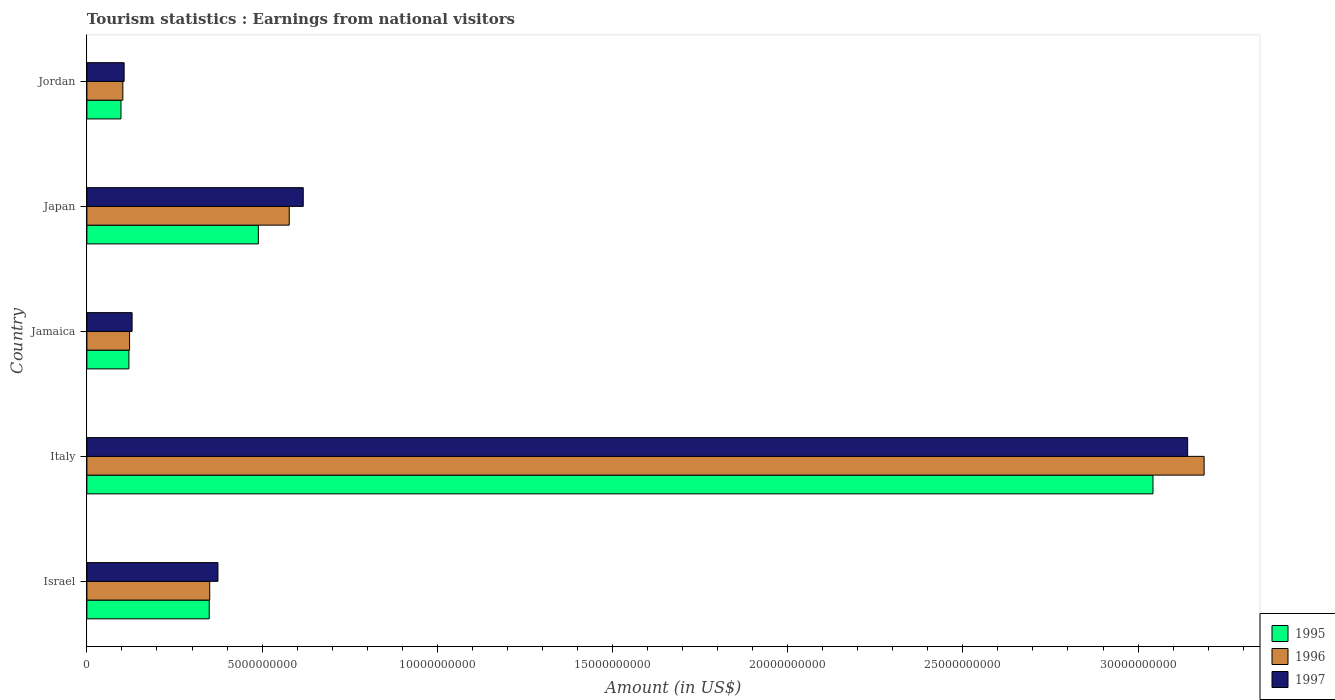How many different coloured bars are there?
Offer a very short reply. 3. Are the number of bars on each tick of the Y-axis equal?
Ensure brevity in your answer.  Yes. How many bars are there on the 1st tick from the bottom?
Keep it short and to the point. 3. What is the label of the 3rd group of bars from the top?
Ensure brevity in your answer.  Jamaica. In how many cases, is the number of bars for a given country not equal to the number of legend labels?
Your response must be concise. 0. What is the earnings from national visitors in 1995 in Italy?
Give a very brief answer. 3.04e+1. Across all countries, what is the maximum earnings from national visitors in 1997?
Your response must be concise. 3.14e+1. Across all countries, what is the minimum earnings from national visitors in 1996?
Provide a succinct answer. 1.03e+09. In which country was the earnings from national visitors in 1995 minimum?
Ensure brevity in your answer.  Jordan. What is the total earnings from national visitors in 1995 in the graph?
Your answer should be very brief. 4.10e+1. What is the difference between the earnings from national visitors in 1996 in Japan and that in Jordan?
Provide a short and direct response. 4.75e+09. What is the difference between the earnings from national visitors in 1997 in Italy and the earnings from national visitors in 1996 in Japan?
Your answer should be compact. 2.56e+1. What is the average earnings from national visitors in 1997 per country?
Provide a short and direct response. 8.74e+09. What is the difference between the earnings from national visitors in 1996 and earnings from national visitors in 1997 in Israel?
Give a very brief answer. -2.34e+08. In how many countries, is the earnings from national visitors in 1997 greater than 30000000000 US$?
Ensure brevity in your answer.  1. What is the ratio of the earnings from national visitors in 1997 in Japan to that in Jordan?
Provide a short and direct response. 5.81. Is the earnings from national visitors in 1996 in Israel less than that in Jordan?
Your answer should be very brief. No. Is the difference between the earnings from national visitors in 1996 in Italy and Jordan greater than the difference between the earnings from national visitors in 1997 in Italy and Jordan?
Your answer should be compact. Yes. What is the difference between the highest and the second highest earnings from national visitors in 1996?
Your answer should be compact. 2.61e+1. What is the difference between the highest and the lowest earnings from national visitors in 1995?
Ensure brevity in your answer.  2.95e+1. In how many countries, is the earnings from national visitors in 1995 greater than the average earnings from national visitors in 1995 taken over all countries?
Provide a short and direct response. 1. Is the sum of the earnings from national visitors in 1996 in Israel and Jamaica greater than the maximum earnings from national visitors in 1997 across all countries?
Provide a succinct answer. No. What does the 3rd bar from the top in Jamaica represents?
Provide a succinct answer. 1995. Is it the case that in every country, the sum of the earnings from national visitors in 1997 and earnings from national visitors in 1995 is greater than the earnings from national visitors in 1996?
Your answer should be compact. Yes. How many bars are there?
Provide a short and direct response. 15. How many countries are there in the graph?
Ensure brevity in your answer.  5. What is the difference between two consecutive major ticks on the X-axis?
Provide a succinct answer. 5.00e+09. Are the values on the major ticks of X-axis written in scientific E-notation?
Offer a terse response. No. Where does the legend appear in the graph?
Your answer should be compact. Bottom right. What is the title of the graph?
Your response must be concise. Tourism statistics : Earnings from national visitors. Does "1972" appear as one of the legend labels in the graph?
Your answer should be compact. No. What is the Amount (in US$) of 1995 in Israel?
Give a very brief answer. 3.49e+09. What is the Amount (in US$) in 1996 in Israel?
Offer a very short reply. 3.51e+09. What is the Amount (in US$) in 1997 in Israel?
Offer a terse response. 3.74e+09. What is the Amount (in US$) in 1995 in Italy?
Make the answer very short. 3.04e+1. What is the Amount (in US$) of 1996 in Italy?
Provide a succinct answer. 3.19e+1. What is the Amount (in US$) in 1997 in Italy?
Keep it short and to the point. 3.14e+1. What is the Amount (in US$) in 1995 in Jamaica?
Your answer should be very brief. 1.20e+09. What is the Amount (in US$) of 1996 in Jamaica?
Offer a very short reply. 1.22e+09. What is the Amount (in US$) of 1997 in Jamaica?
Provide a short and direct response. 1.29e+09. What is the Amount (in US$) of 1995 in Japan?
Give a very brief answer. 4.89e+09. What is the Amount (in US$) of 1996 in Japan?
Give a very brief answer. 5.78e+09. What is the Amount (in US$) of 1997 in Japan?
Make the answer very short. 6.18e+09. What is the Amount (in US$) of 1995 in Jordan?
Offer a terse response. 9.73e+08. What is the Amount (in US$) in 1996 in Jordan?
Make the answer very short. 1.03e+09. What is the Amount (in US$) in 1997 in Jordan?
Offer a very short reply. 1.06e+09. Across all countries, what is the maximum Amount (in US$) in 1995?
Offer a terse response. 3.04e+1. Across all countries, what is the maximum Amount (in US$) in 1996?
Provide a short and direct response. 3.19e+1. Across all countries, what is the maximum Amount (in US$) in 1997?
Your response must be concise. 3.14e+1. Across all countries, what is the minimum Amount (in US$) in 1995?
Your response must be concise. 9.73e+08. Across all countries, what is the minimum Amount (in US$) in 1996?
Your response must be concise. 1.03e+09. Across all countries, what is the minimum Amount (in US$) in 1997?
Offer a terse response. 1.06e+09. What is the total Amount (in US$) of 1995 in the graph?
Offer a terse response. 4.10e+1. What is the total Amount (in US$) in 1996 in the graph?
Offer a very short reply. 4.34e+1. What is the total Amount (in US$) of 1997 in the graph?
Offer a terse response. 4.37e+1. What is the difference between the Amount (in US$) in 1995 in Israel and that in Italy?
Make the answer very short. -2.69e+1. What is the difference between the Amount (in US$) of 1996 in Israel and that in Italy?
Provide a succinct answer. -2.84e+1. What is the difference between the Amount (in US$) in 1997 in Israel and that in Italy?
Offer a terse response. -2.77e+1. What is the difference between the Amount (in US$) in 1995 in Israel and that in Jamaica?
Keep it short and to the point. 2.29e+09. What is the difference between the Amount (in US$) of 1996 in Israel and that in Jamaica?
Keep it short and to the point. 2.29e+09. What is the difference between the Amount (in US$) in 1997 in Israel and that in Jamaica?
Offer a very short reply. 2.45e+09. What is the difference between the Amount (in US$) in 1995 in Israel and that in Japan?
Your answer should be compact. -1.40e+09. What is the difference between the Amount (in US$) of 1996 in Israel and that in Japan?
Your answer should be very brief. -2.27e+09. What is the difference between the Amount (in US$) of 1997 in Israel and that in Japan?
Ensure brevity in your answer.  -2.44e+09. What is the difference between the Amount (in US$) of 1995 in Israel and that in Jordan?
Offer a terse response. 2.52e+09. What is the difference between the Amount (in US$) in 1996 in Israel and that in Jordan?
Provide a short and direct response. 2.48e+09. What is the difference between the Amount (in US$) in 1997 in Israel and that in Jordan?
Keep it short and to the point. 2.68e+09. What is the difference between the Amount (in US$) in 1995 in Italy and that in Jamaica?
Offer a very short reply. 2.92e+1. What is the difference between the Amount (in US$) in 1996 in Italy and that in Jamaica?
Offer a very short reply. 3.07e+1. What is the difference between the Amount (in US$) in 1997 in Italy and that in Jamaica?
Your answer should be compact. 3.01e+1. What is the difference between the Amount (in US$) of 1995 in Italy and that in Japan?
Provide a short and direct response. 2.55e+1. What is the difference between the Amount (in US$) in 1996 in Italy and that in Japan?
Your answer should be very brief. 2.61e+1. What is the difference between the Amount (in US$) in 1997 in Italy and that in Japan?
Provide a short and direct response. 2.52e+1. What is the difference between the Amount (in US$) of 1995 in Italy and that in Jordan?
Your answer should be compact. 2.95e+1. What is the difference between the Amount (in US$) in 1996 in Italy and that in Jordan?
Make the answer very short. 3.09e+1. What is the difference between the Amount (in US$) of 1997 in Italy and that in Jordan?
Provide a succinct answer. 3.04e+1. What is the difference between the Amount (in US$) in 1995 in Jamaica and that in Japan?
Your answer should be very brief. -3.70e+09. What is the difference between the Amount (in US$) of 1996 in Jamaica and that in Japan?
Make the answer very short. -4.56e+09. What is the difference between the Amount (in US$) of 1997 in Jamaica and that in Japan?
Provide a succinct answer. -4.88e+09. What is the difference between the Amount (in US$) in 1995 in Jamaica and that in Jordan?
Provide a short and direct response. 2.26e+08. What is the difference between the Amount (in US$) of 1996 in Jamaica and that in Jordan?
Keep it short and to the point. 1.92e+08. What is the difference between the Amount (in US$) in 1997 in Jamaica and that in Jordan?
Offer a very short reply. 2.27e+08. What is the difference between the Amount (in US$) of 1995 in Japan and that in Jordan?
Ensure brevity in your answer.  3.92e+09. What is the difference between the Amount (in US$) in 1996 in Japan and that in Jordan?
Offer a very short reply. 4.75e+09. What is the difference between the Amount (in US$) in 1997 in Japan and that in Jordan?
Provide a short and direct response. 5.11e+09. What is the difference between the Amount (in US$) of 1995 in Israel and the Amount (in US$) of 1996 in Italy?
Provide a succinct answer. -2.84e+1. What is the difference between the Amount (in US$) in 1995 in Israel and the Amount (in US$) in 1997 in Italy?
Provide a short and direct response. -2.79e+1. What is the difference between the Amount (in US$) in 1996 in Israel and the Amount (in US$) in 1997 in Italy?
Your answer should be very brief. -2.79e+1. What is the difference between the Amount (in US$) of 1995 in Israel and the Amount (in US$) of 1996 in Jamaica?
Keep it short and to the point. 2.27e+09. What is the difference between the Amount (in US$) of 1995 in Israel and the Amount (in US$) of 1997 in Jamaica?
Provide a short and direct response. 2.20e+09. What is the difference between the Amount (in US$) of 1996 in Israel and the Amount (in US$) of 1997 in Jamaica?
Give a very brief answer. 2.22e+09. What is the difference between the Amount (in US$) in 1995 in Israel and the Amount (in US$) in 1996 in Japan?
Your answer should be very brief. -2.28e+09. What is the difference between the Amount (in US$) of 1995 in Israel and the Amount (in US$) of 1997 in Japan?
Ensure brevity in your answer.  -2.68e+09. What is the difference between the Amount (in US$) of 1996 in Israel and the Amount (in US$) of 1997 in Japan?
Provide a short and direct response. -2.67e+09. What is the difference between the Amount (in US$) of 1995 in Israel and the Amount (in US$) of 1996 in Jordan?
Your answer should be compact. 2.46e+09. What is the difference between the Amount (in US$) in 1995 in Israel and the Amount (in US$) in 1997 in Jordan?
Your response must be concise. 2.43e+09. What is the difference between the Amount (in US$) in 1996 in Israel and the Amount (in US$) in 1997 in Jordan?
Ensure brevity in your answer.  2.44e+09. What is the difference between the Amount (in US$) of 1995 in Italy and the Amount (in US$) of 1996 in Jamaica?
Your answer should be very brief. 2.92e+1. What is the difference between the Amount (in US$) of 1995 in Italy and the Amount (in US$) of 1997 in Jamaica?
Provide a succinct answer. 2.91e+1. What is the difference between the Amount (in US$) of 1996 in Italy and the Amount (in US$) of 1997 in Jamaica?
Your answer should be compact. 3.06e+1. What is the difference between the Amount (in US$) in 1995 in Italy and the Amount (in US$) in 1996 in Japan?
Your response must be concise. 2.47e+1. What is the difference between the Amount (in US$) of 1995 in Italy and the Amount (in US$) of 1997 in Japan?
Your answer should be compact. 2.43e+1. What is the difference between the Amount (in US$) of 1996 in Italy and the Amount (in US$) of 1997 in Japan?
Your response must be concise. 2.57e+1. What is the difference between the Amount (in US$) of 1995 in Italy and the Amount (in US$) of 1996 in Jordan?
Keep it short and to the point. 2.94e+1. What is the difference between the Amount (in US$) of 1995 in Italy and the Amount (in US$) of 1997 in Jordan?
Make the answer very short. 2.94e+1. What is the difference between the Amount (in US$) of 1996 in Italy and the Amount (in US$) of 1997 in Jordan?
Provide a succinct answer. 3.08e+1. What is the difference between the Amount (in US$) in 1995 in Jamaica and the Amount (in US$) in 1996 in Japan?
Provide a succinct answer. -4.58e+09. What is the difference between the Amount (in US$) of 1995 in Jamaica and the Amount (in US$) of 1997 in Japan?
Provide a short and direct response. -4.98e+09. What is the difference between the Amount (in US$) of 1996 in Jamaica and the Amount (in US$) of 1997 in Japan?
Your response must be concise. -4.96e+09. What is the difference between the Amount (in US$) of 1995 in Jamaica and the Amount (in US$) of 1996 in Jordan?
Make the answer very short. 1.73e+08. What is the difference between the Amount (in US$) in 1995 in Jamaica and the Amount (in US$) in 1997 in Jordan?
Offer a terse response. 1.36e+08. What is the difference between the Amount (in US$) in 1996 in Jamaica and the Amount (in US$) in 1997 in Jordan?
Give a very brief answer. 1.55e+08. What is the difference between the Amount (in US$) of 1995 in Japan and the Amount (in US$) of 1996 in Jordan?
Ensure brevity in your answer.  3.87e+09. What is the difference between the Amount (in US$) in 1995 in Japan and the Amount (in US$) in 1997 in Jordan?
Your answer should be compact. 3.83e+09. What is the difference between the Amount (in US$) of 1996 in Japan and the Amount (in US$) of 1997 in Jordan?
Keep it short and to the point. 4.71e+09. What is the average Amount (in US$) in 1995 per country?
Ensure brevity in your answer.  8.20e+09. What is the average Amount (in US$) in 1996 per country?
Ensure brevity in your answer.  8.68e+09. What is the average Amount (in US$) in 1997 per country?
Your answer should be very brief. 8.74e+09. What is the difference between the Amount (in US$) in 1995 and Amount (in US$) in 1996 in Israel?
Provide a succinct answer. -1.50e+07. What is the difference between the Amount (in US$) in 1995 and Amount (in US$) in 1997 in Israel?
Your response must be concise. -2.49e+08. What is the difference between the Amount (in US$) of 1996 and Amount (in US$) of 1997 in Israel?
Give a very brief answer. -2.34e+08. What is the difference between the Amount (in US$) of 1995 and Amount (in US$) of 1996 in Italy?
Ensure brevity in your answer.  -1.46e+09. What is the difference between the Amount (in US$) of 1995 and Amount (in US$) of 1997 in Italy?
Your answer should be very brief. -9.90e+08. What is the difference between the Amount (in US$) of 1996 and Amount (in US$) of 1997 in Italy?
Your answer should be compact. 4.70e+08. What is the difference between the Amount (in US$) in 1995 and Amount (in US$) in 1996 in Jamaica?
Your answer should be very brief. -1.90e+07. What is the difference between the Amount (in US$) in 1995 and Amount (in US$) in 1997 in Jamaica?
Your answer should be very brief. -9.10e+07. What is the difference between the Amount (in US$) in 1996 and Amount (in US$) in 1997 in Jamaica?
Offer a very short reply. -7.20e+07. What is the difference between the Amount (in US$) in 1995 and Amount (in US$) in 1996 in Japan?
Give a very brief answer. -8.81e+08. What is the difference between the Amount (in US$) in 1995 and Amount (in US$) in 1997 in Japan?
Ensure brevity in your answer.  -1.28e+09. What is the difference between the Amount (in US$) of 1996 and Amount (in US$) of 1997 in Japan?
Make the answer very short. -4.00e+08. What is the difference between the Amount (in US$) in 1995 and Amount (in US$) in 1996 in Jordan?
Ensure brevity in your answer.  -5.30e+07. What is the difference between the Amount (in US$) in 1995 and Amount (in US$) in 1997 in Jordan?
Give a very brief answer. -9.00e+07. What is the difference between the Amount (in US$) of 1996 and Amount (in US$) of 1997 in Jordan?
Keep it short and to the point. -3.70e+07. What is the ratio of the Amount (in US$) of 1995 in Israel to that in Italy?
Give a very brief answer. 0.11. What is the ratio of the Amount (in US$) of 1996 in Israel to that in Italy?
Offer a terse response. 0.11. What is the ratio of the Amount (in US$) in 1997 in Israel to that in Italy?
Offer a terse response. 0.12. What is the ratio of the Amount (in US$) in 1995 in Israel to that in Jamaica?
Keep it short and to the point. 2.91. What is the ratio of the Amount (in US$) in 1996 in Israel to that in Jamaica?
Keep it short and to the point. 2.88. What is the ratio of the Amount (in US$) in 1997 in Israel to that in Jamaica?
Make the answer very short. 2.9. What is the ratio of the Amount (in US$) in 1995 in Israel to that in Japan?
Ensure brevity in your answer.  0.71. What is the ratio of the Amount (in US$) in 1996 in Israel to that in Japan?
Offer a terse response. 0.61. What is the ratio of the Amount (in US$) in 1997 in Israel to that in Japan?
Ensure brevity in your answer.  0.61. What is the ratio of the Amount (in US$) of 1995 in Israel to that in Jordan?
Your response must be concise. 3.59. What is the ratio of the Amount (in US$) of 1996 in Israel to that in Jordan?
Give a very brief answer. 3.42. What is the ratio of the Amount (in US$) in 1997 in Israel to that in Jordan?
Keep it short and to the point. 3.52. What is the ratio of the Amount (in US$) of 1995 in Italy to that in Jamaica?
Your answer should be very brief. 25.38. What is the ratio of the Amount (in US$) in 1996 in Italy to that in Jamaica?
Provide a succinct answer. 26.18. What is the ratio of the Amount (in US$) in 1997 in Italy to that in Jamaica?
Offer a very short reply. 24.35. What is the ratio of the Amount (in US$) of 1995 in Italy to that in Japan?
Your answer should be compact. 6.22. What is the ratio of the Amount (in US$) of 1996 in Italy to that in Japan?
Make the answer very short. 5.52. What is the ratio of the Amount (in US$) in 1997 in Italy to that in Japan?
Keep it short and to the point. 5.09. What is the ratio of the Amount (in US$) of 1995 in Italy to that in Jordan?
Your answer should be compact. 31.27. What is the ratio of the Amount (in US$) of 1996 in Italy to that in Jordan?
Make the answer very short. 31.08. What is the ratio of the Amount (in US$) of 1997 in Italy to that in Jordan?
Provide a succinct answer. 29.55. What is the ratio of the Amount (in US$) of 1995 in Jamaica to that in Japan?
Your answer should be compact. 0.24. What is the ratio of the Amount (in US$) of 1996 in Jamaica to that in Japan?
Provide a succinct answer. 0.21. What is the ratio of the Amount (in US$) of 1997 in Jamaica to that in Japan?
Your answer should be very brief. 0.21. What is the ratio of the Amount (in US$) in 1995 in Jamaica to that in Jordan?
Provide a succinct answer. 1.23. What is the ratio of the Amount (in US$) in 1996 in Jamaica to that in Jordan?
Offer a terse response. 1.19. What is the ratio of the Amount (in US$) of 1997 in Jamaica to that in Jordan?
Give a very brief answer. 1.21. What is the ratio of the Amount (in US$) in 1995 in Japan to that in Jordan?
Your answer should be compact. 5.03. What is the ratio of the Amount (in US$) of 1996 in Japan to that in Jordan?
Provide a succinct answer. 5.63. What is the ratio of the Amount (in US$) of 1997 in Japan to that in Jordan?
Make the answer very short. 5.81. What is the difference between the highest and the second highest Amount (in US$) in 1995?
Your response must be concise. 2.55e+1. What is the difference between the highest and the second highest Amount (in US$) of 1996?
Your answer should be very brief. 2.61e+1. What is the difference between the highest and the second highest Amount (in US$) in 1997?
Provide a short and direct response. 2.52e+1. What is the difference between the highest and the lowest Amount (in US$) in 1995?
Your answer should be compact. 2.95e+1. What is the difference between the highest and the lowest Amount (in US$) of 1996?
Provide a succinct answer. 3.09e+1. What is the difference between the highest and the lowest Amount (in US$) in 1997?
Your answer should be compact. 3.04e+1. 